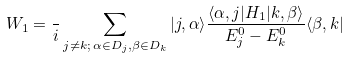Convert formula to latex. <formula><loc_0><loc_0><loc_500><loc_500>W _ { 1 } = \frac { } { i } \sum _ { j \neq k ; \, \alpha \in D _ { j } , \beta \in D _ { k } } | j , \alpha \rangle \frac { \langle \alpha , j | H _ { 1 } | k , \beta \rangle } { E ^ { 0 } _ { j } - E ^ { 0 } _ { k } } \langle \beta , k |</formula> 